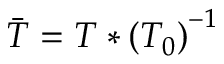<formula> <loc_0><loc_0><loc_500><loc_500>\ B a r { T } = T * \left ( T _ { 0 } \right ) ^ { - 1 }</formula> 